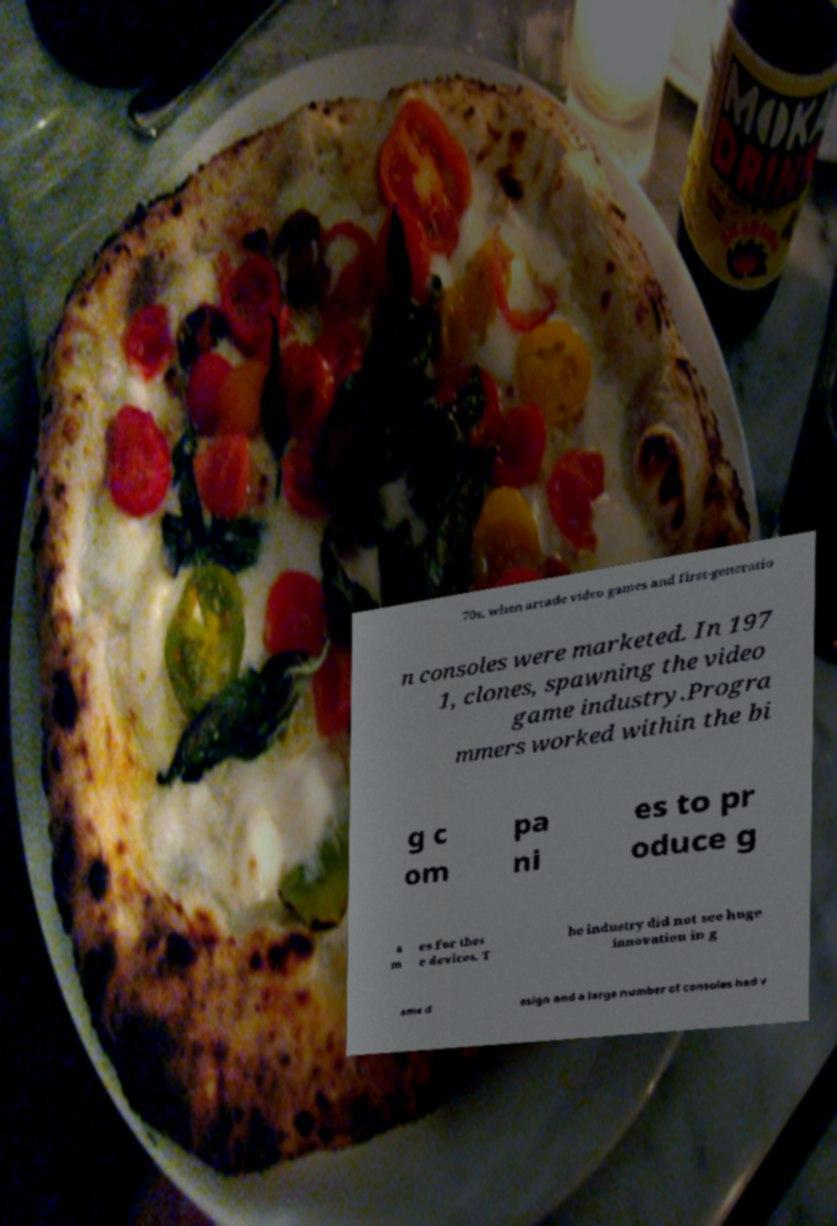Please read and relay the text visible in this image. What does it say? 70s, when arcade video games and first-generatio n consoles were marketed. In 197 1, clones, spawning the video game industry.Progra mmers worked within the bi g c om pa ni es to pr oduce g a m es for thes e devices. T he industry did not see huge innovation in g ame d esign and a large number of consoles had v 